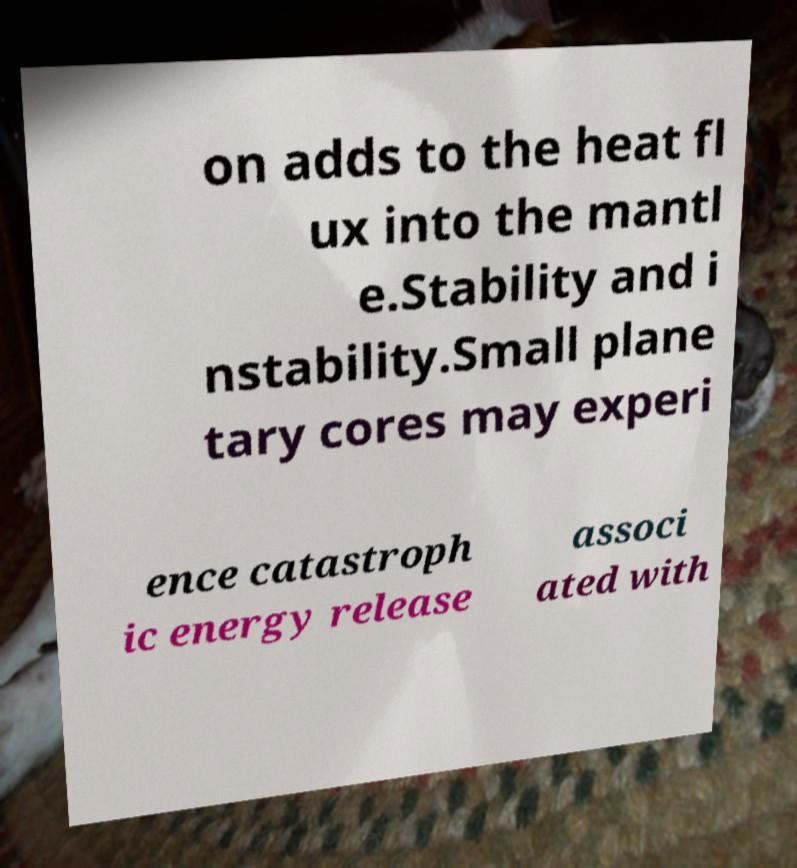There's text embedded in this image that I need extracted. Can you transcribe it verbatim? on adds to the heat fl ux into the mantl e.Stability and i nstability.Small plane tary cores may experi ence catastroph ic energy release associ ated with 